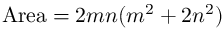<formula> <loc_0><loc_0><loc_500><loc_500>{ A r e a } = 2 m n ( m ^ { 2 } + 2 n ^ { 2 } )</formula> 